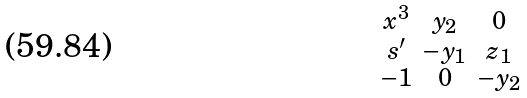<formula> <loc_0><loc_0><loc_500><loc_500>\begin{smallmatrix} x ^ { 3 } & y _ { 2 } & 0 \\ s ^ { \prime } & - y _ { 1 } & z _ { 1 } \\ - 1 & 0 & - y _ { 2 } \end{smallmatrix}</formula> 